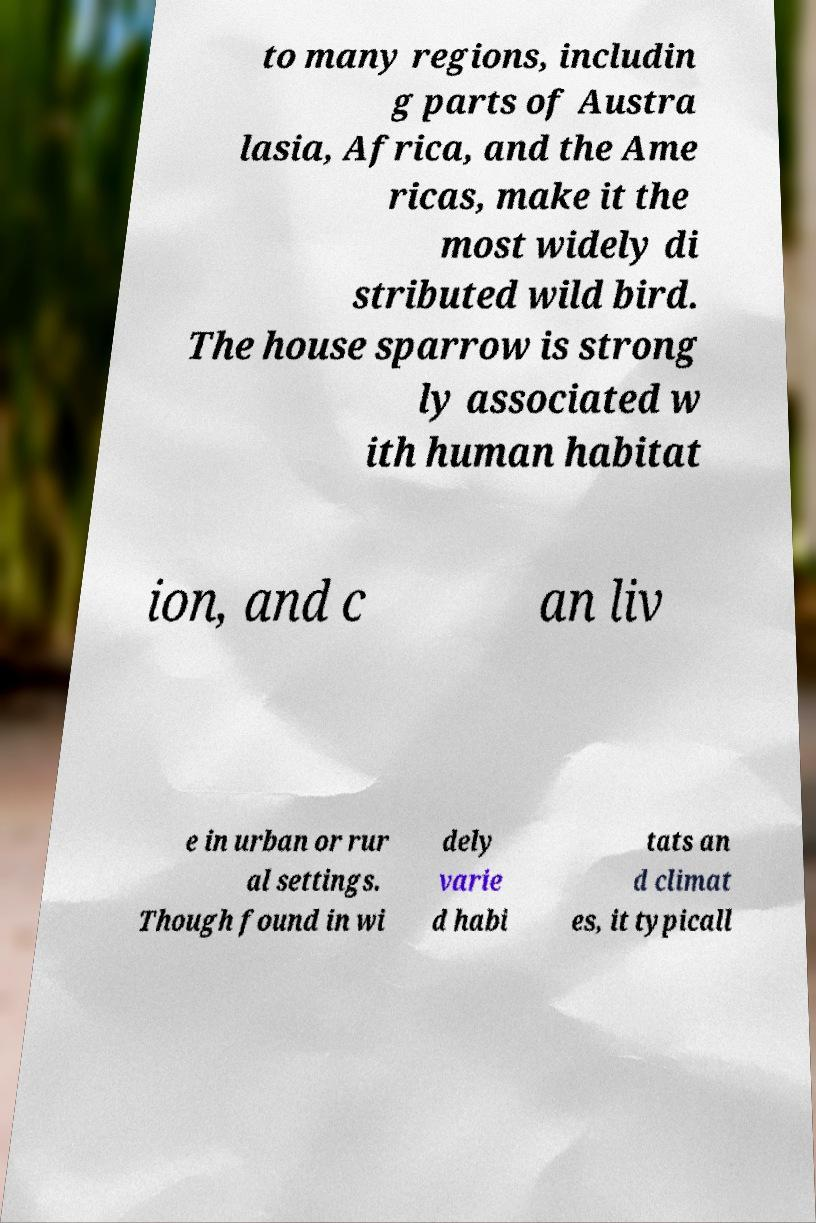Please read and relay the text visible in this image. What does it say? to many regions, includin g parts of Austra lasia, Africa, and the Ame ricas, make it the most widely di stributed wild bird. The house sparrow is strong ly associated w ith human habitat ion, and c an liv e in urban or rur al settings. Though found in wi dely varie d habi tats an d climat es, it typicall 